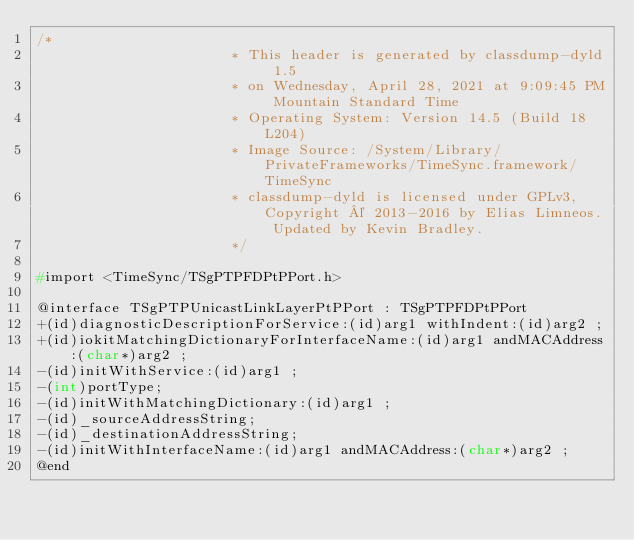Convert code to text. <code><loc_0><loc_0><loc_500><loc_500><_C_>/*
                       * This header is generated by classdump-dyld 1.5
                       * on Wednesday, April 28, 2021 at 9:09:45 PM Mountain Standard Time
                       * Operating System: Version 14.5 (Build 18L204)
                       * Image Source: /System/Library/PrivateFrameworks/TimeSync.framework/TimeSync
                       * classdump-dyld is licensed under GPLv3, Copyright © 2013-2016 by Elias Limneos. Updated by Kevin Bradley.
                       */

#import <TimeSync/TSgPTPFDPtPPort.h>

@interface TSgPTPUnicastLinkLayerPtPPort : TSgPTPFDPtPPort
+(id)diagnosticDescriptionForService:(id)arg1 withIndent:(id)arg2 ;
+(id)iokitMatchingDictionaryForInterfaceName:(id)arg1 andMACAddress:(char*)arg2 ;
-(id)initWithService:(id)arg1 ;
-(int)portType;
-(id)initWithMatchingDictionary:(id)arg1 ;
-(id)_sourceAddressString;
-(id)_destinationAddressString;
-(id)initWithInterfaceName:(id)arg1 andMACAddress:(char*)arg2 ;
@end

</code> 